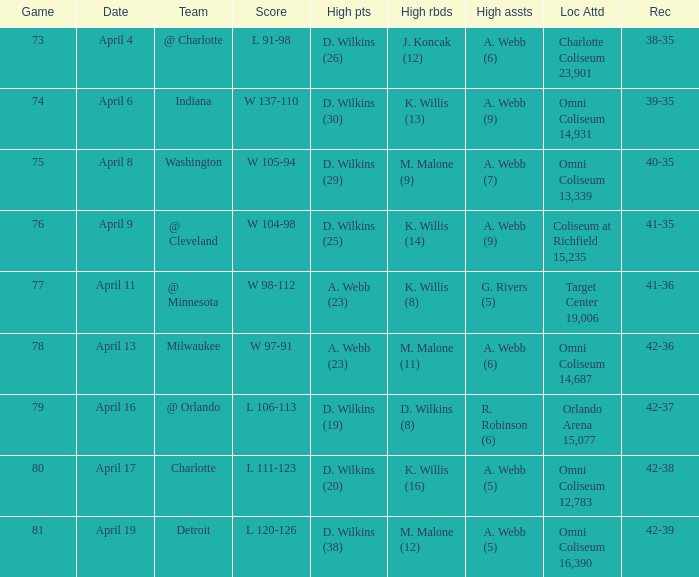What was the date of the game when g. rivers (5) had the  high assists? April 11. 